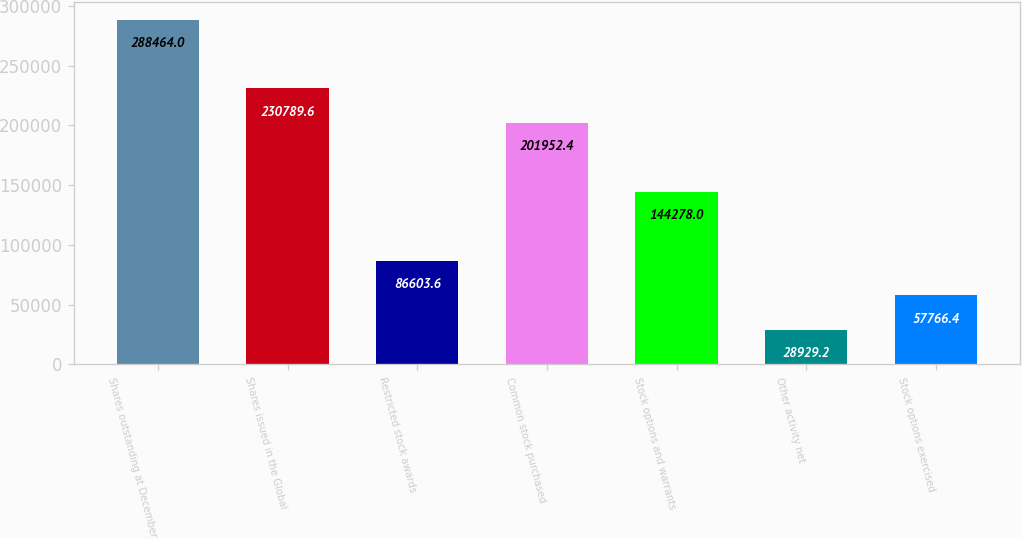Convert chart. <chart><loc_0><loc_0><loc_500><loc_500><bar_chart><fcel>Shares outstanding at December<fcel>Shares issued in the Global<fcel>Restricted stock awards<fcel>Common stock purchased<fcel>Stock options and warrants<fcel>Other activity net<fcel>Stock options exercised<nl><fcel>288464<fcel>230790<fcel>86603.6<fcel>201952<fcel>144278<fcel>28929.2<fcel>57766.4<nl></chart> 